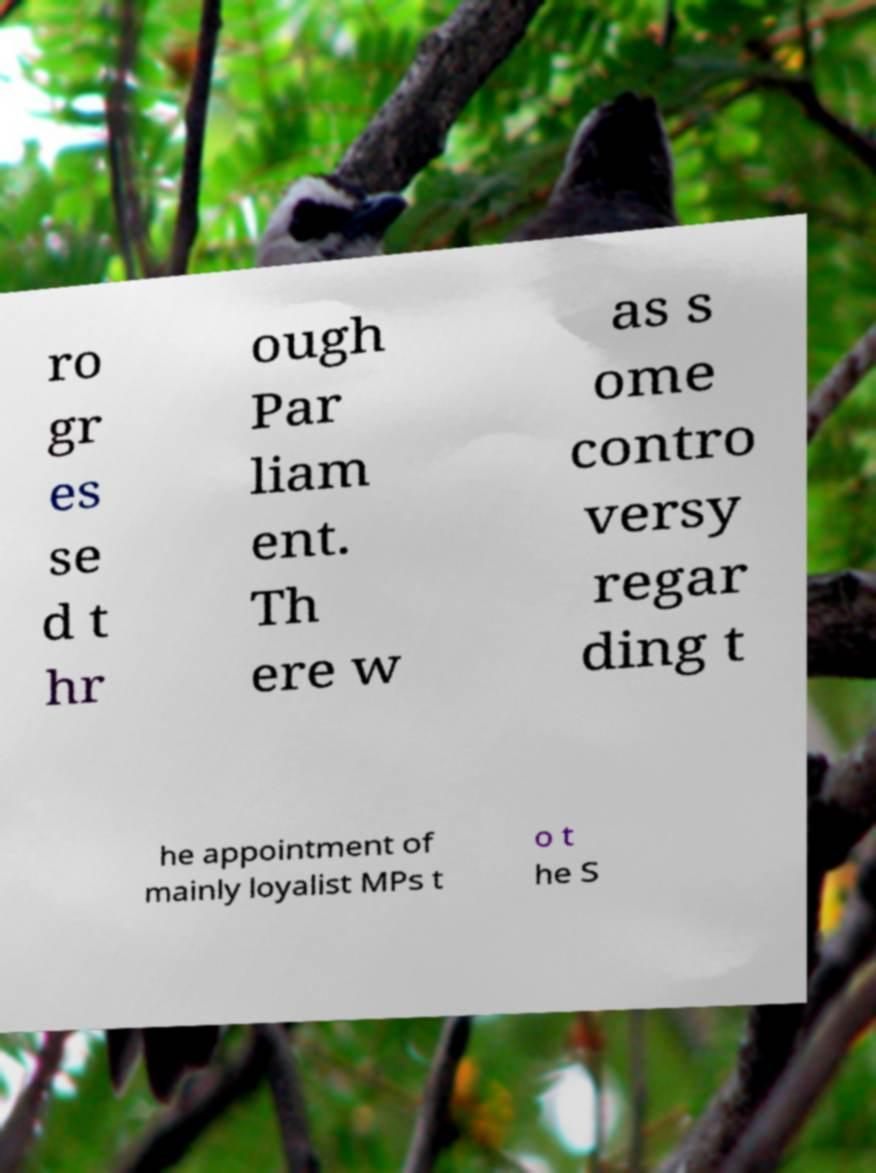For documentation purposes, I need the text within this image transcribed. Could you provide that? ro gr es se d t hr ough Par liam ent. Th ere w as s ome contro versy regar ding t he appointment of mainly loyalist MPs t o t he S 